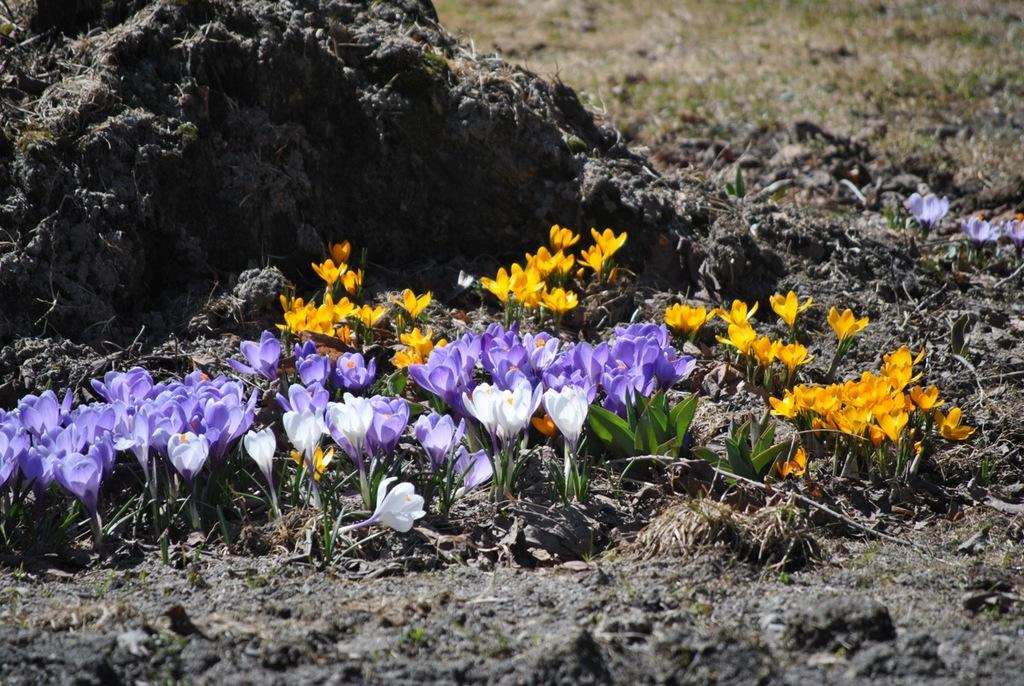What type of plants can be seen in the image? There are flowers and leaves in the image. What is visible in the background of the image? There is grass visible in the background of the image. What type of cannon is being used to draw the flowers in the image? There is no cannon present in the image, and the flowers are not being drawn. 